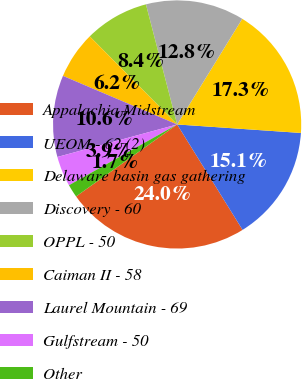<chart> <loc_0><loc_0><loc_500><loc_500><pie_chart><fcel>Appalachia Midstream<fcel>UEOM - 62 (2)<fcel>Delaware basin gas gathering<fcel>Discovery - 60<fcel>OPPL - 50<fcel>Caiman II - 58<fcel>Laurel Mountain - 69<fcel>Gulfstream - 50<fcel>Other<nl><fcel>23.99%<fcel>15.07%<fcel>17.3%<fcel>12.84%<fcel>8.39%<fcel>6.16%<fcel>10.62%<fcel>3.93%<fcel>1.7%<nl></chart> 